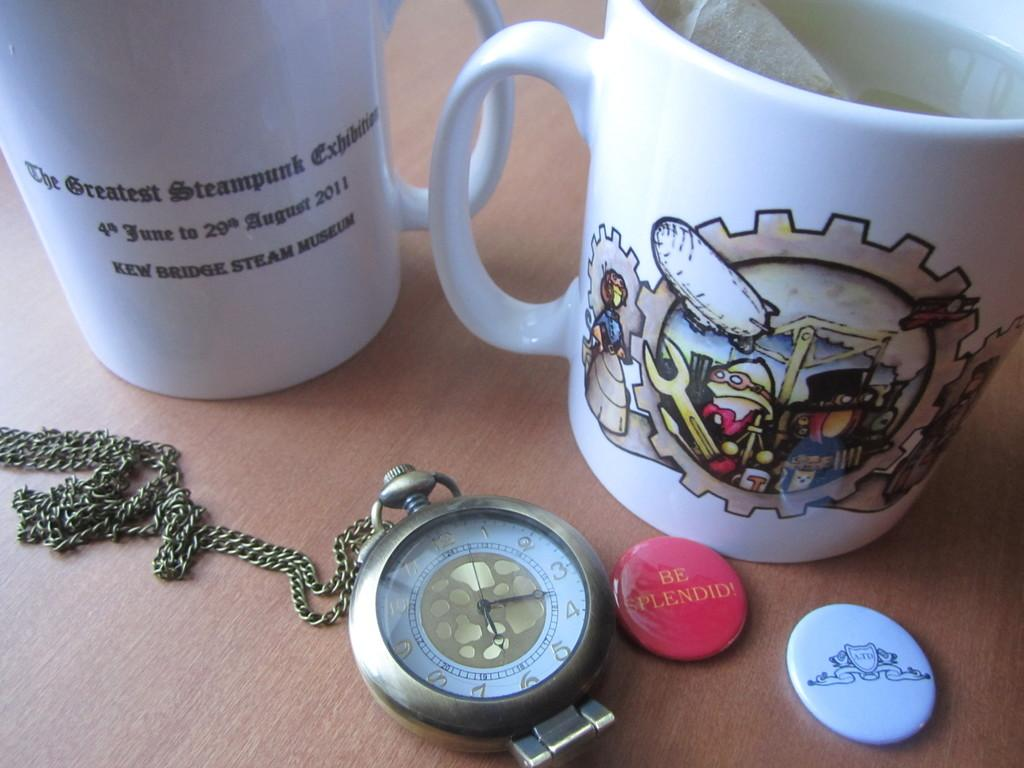Provide a one-sentence caption for the provided image. A white mug near other items advertises "The Greatest Steampunk Exhibit". 